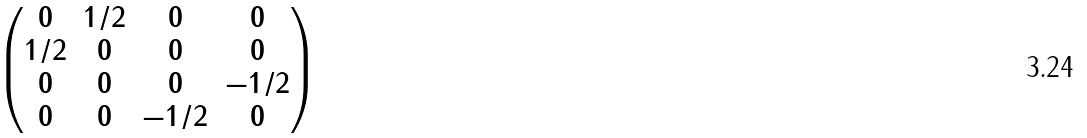Convert formula to latex. <formula><loc_0><loc_0><loc_500><loc_500>\begin{pmatrix} 0 & 1 / 2 & 0 & 0 \\ 1 / 2 & 0 & 0 & 0 \\ 0 & 0 & 0 & - 1 / 2 \\ 0 & 0 & - 1 / 2 & 0 \end{pmatrix}</formula> 